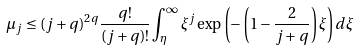Convert formula to latex. <formula><loc_0><loc_0><loc_500><loc_500>\mu _ { j } \leq ( j + q ) ^ { 2 q } \frac { q ! } { ( j + q ) ! } \int _ { \eta } ^ { \infty } \xi ^ { j } \exp \left ( - \left ( 1 - \frac { 2 } { j + q } \right ) \xi \right ) d \xi</formula> 